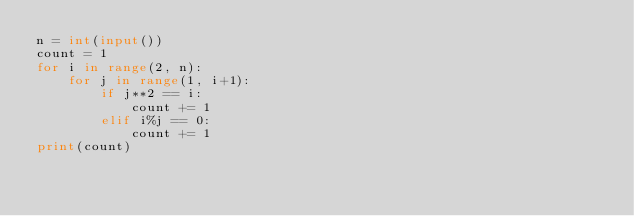Convert code to text. <code><loc_0><loc_0><loc_500><loc_500><_Python_>n = int(input())
count = 1
for i in range(2, n):
    for j in range(1, i+1):
        if j**2 == i:
            count += 1
        elif i%j == 0:
            count += 1
print(count)</code> 